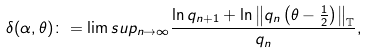<formula> <loc_0><loc_0><loc_500><loc_500>\delta ( \alpha , \theta ) \colon = \lim s u p _ { n \rightarrow \infty } \frac { \ln q _ { n + 1 } + \ln \left \| q _ { n } \left ( \theta - \frac { 1 } { 2 } \right ) \right \| _ { \mathbb { T } } } { q _ { n } } ,</formula> 